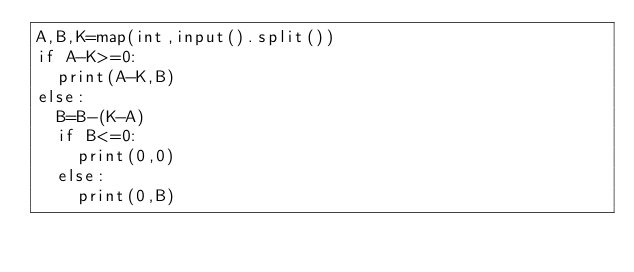Convert code to text. <code><loc_0><loc_0><loc_500><loc_500><_Python_>A,B,K=map(int,input().split())
if A-K>=0:
  print(A-K,B)
else:
  B=B-(K-A)
  if B<=0:
    print(0,0)
  else:
    print(0,B)
  


</code> 